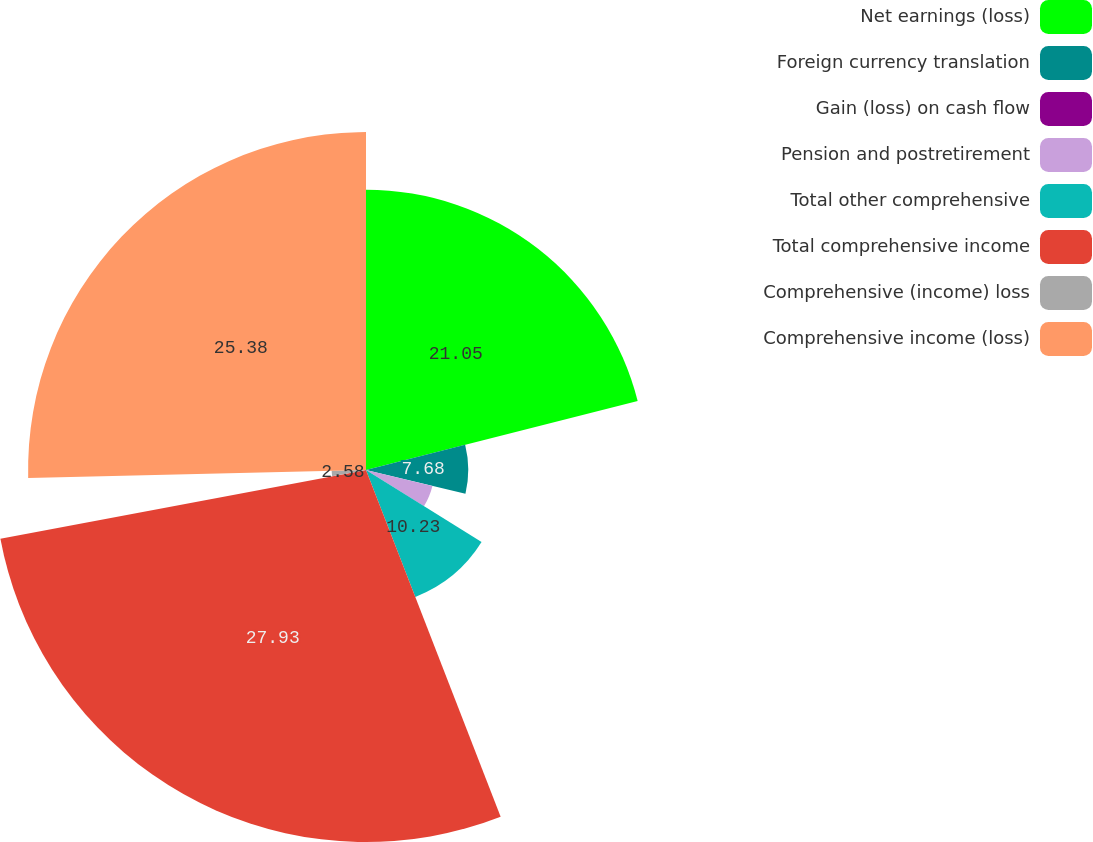Convert chart to OTSL. <chart><loc_0><loc_0><loc_500><loc_500><pie_chart><fcel>Net earnings (loss)<fcel>Foreign currency translation<fcel>Gain (loss) on cash flow<fcel>Pension and postretirement<fcel>Total other comprehensive<fcel>Total comprehensive income<fcel>Comprehensive (income) loss<fcel>Comprehensive income (loss)<nl><fcel>21.05%<fcel>7.68%<fcel>0.02%<fcel>5.13%<fcel>10.23%<fcel>27.94%<fcel>2.58%<fcel>25.38%<nl></chart> 